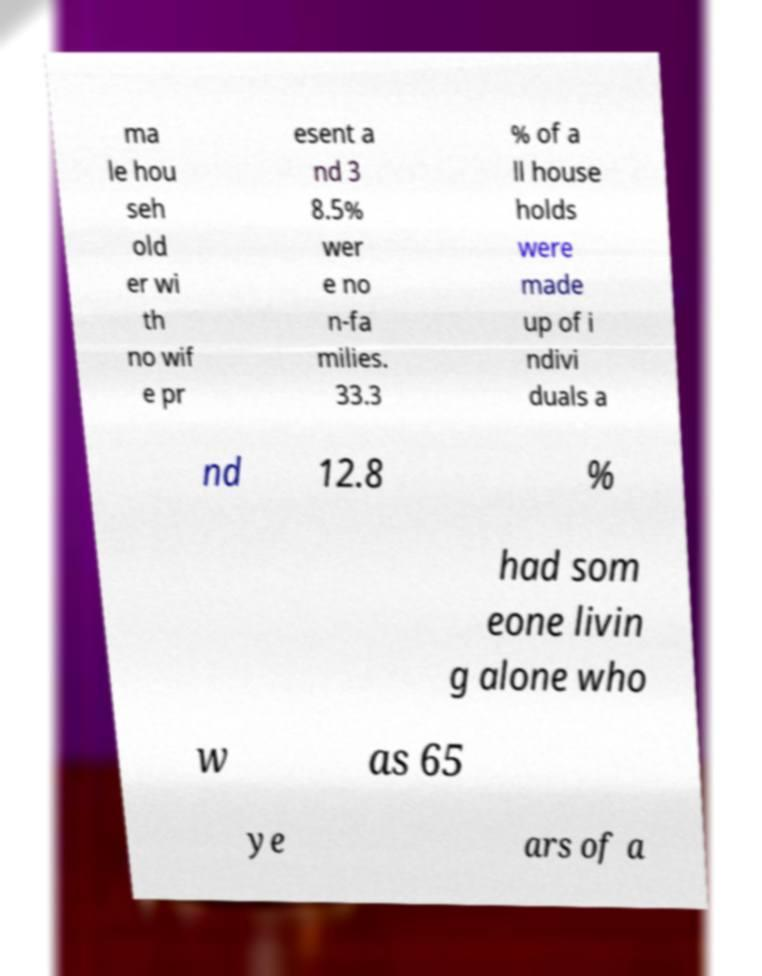Can you read and provide the text displayed in the image?This photo seems to have some interesting text. Can you extract and type it out for me? ma le hou seh old er wi th no wif e pr esent a nd 3 8.5% wer e no n-fa milies. 33.3 % of a ll house holds were made up of i ndivi duals a nd 12.8 % had som eone livin g alone who w as 65 ye ars of a 